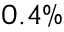Convert formula to latex. <formula><loc_0><loc_0><loc_500><loc_500>0 . 4 \%</formula> 